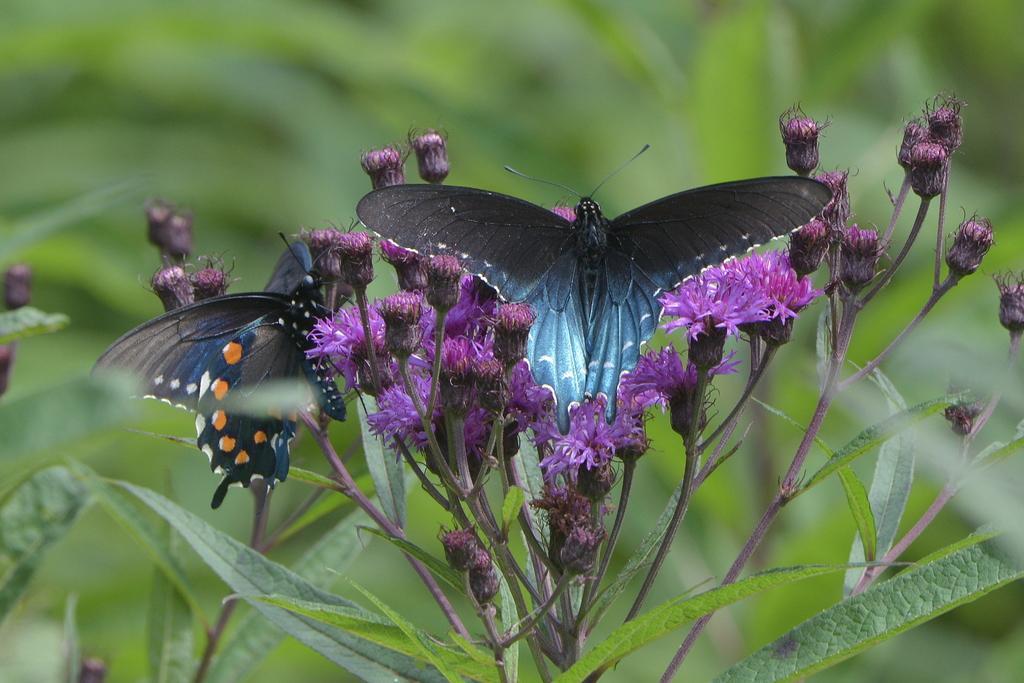Could you give a brief overview of what you see in this image? In the middle of the image we can see some flowers, on the flowers there are two butterflies. At the bottom of the image there are some plants. Background of the image is blur. 